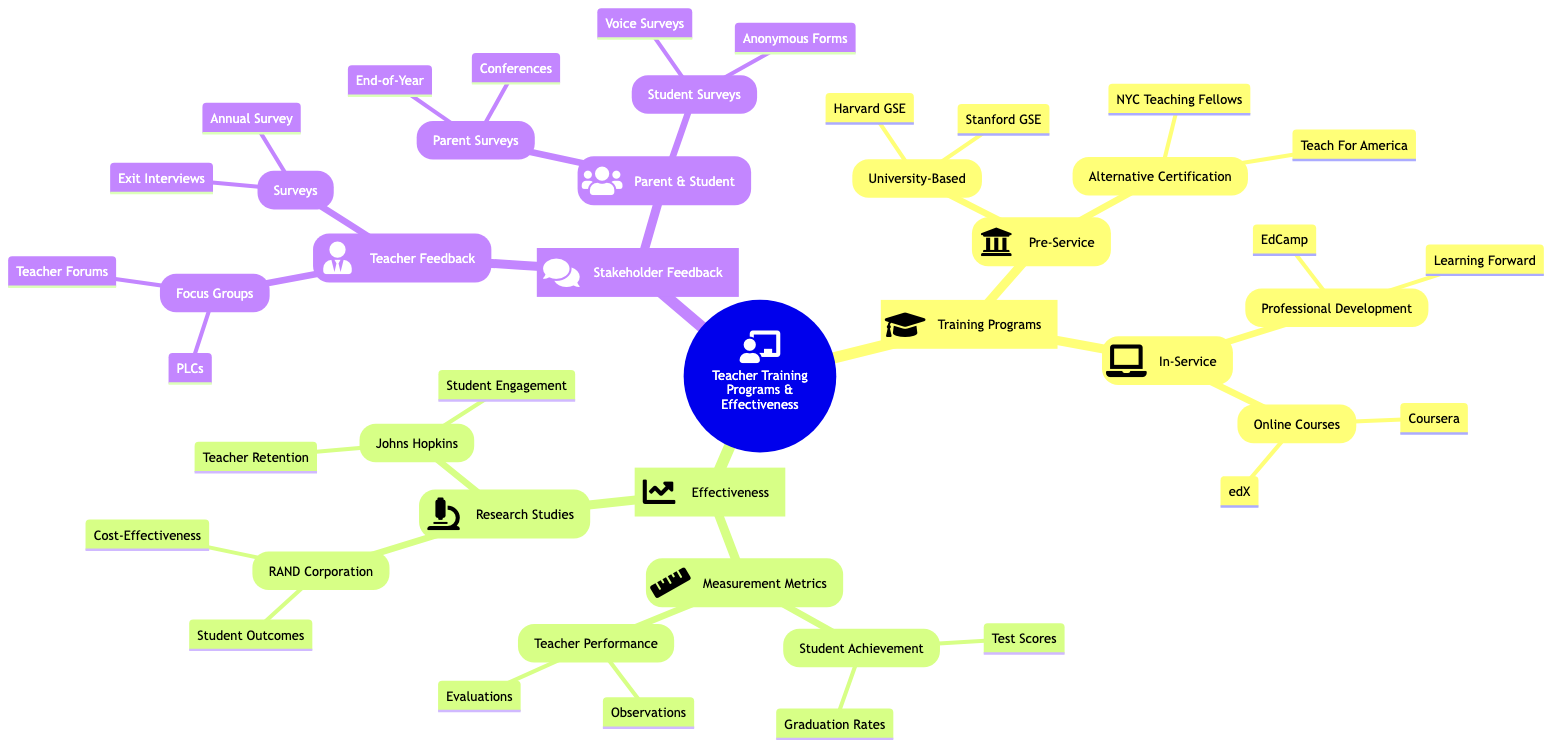What are the two types of Teacher Training Programs? The diagram shows two main categories under Teacher Training Programs: Pre-Service and In-Service training.
Answer: Pre-Service, In-Service How many University-Based programs are listed? In the Pre-Service Training section, under University-Based Programs, there are two specific programs mentioned: Harvard Graduate School of Education and Stanford Graduate School of Education.
Answer: 2 What are the measures used to evaluate Teacher Performance? Under Effectiveness, specifically in the Measurement Metrics, the diagram lists two specific methods for evaluating Teacher Performance: Classroom Observations and Teacher Evaluations.
Answer: Classroom Observations, Teacher Evaluations Which organization is associated with studies on Student Engagement? The Research Studies section of the diagram includes Johns Hopkins University Studies, which specifically mentions Teacher Retention and Student Engagement was associated with this organization.
Answer: Johns Hopkins University What type of feedback is collected from Parents? The Stakeholder Feedback section mentions Parent Surveys, specifically outlining that End-of-Year Surveys and Parent-Teacher Conferences are methods used to collect feedback from parents.
Answer: End-of-Year Surveys, Parent-Teacher Conferences Which In-Service training includes Online Courses? In the In-Service Training section, the diagram categorizes Online Courses under its own sub-category and lists Coursera and edX as the specific examples.
Answer: Coursera, edX What study is associated with Cost-Effectiveness? Under Research Studies, the diagram identifies RAND Corporation Analysis and includes Cost-Effectiveness as one of the topics studied by this organization.
Answer: RAND Corporation Name one method used in Teacher Feedback collection. The diagram shows that in the Teacher Feedback category, there are Surveys as one method used to gather feedback, specifically including Annual Teacher Survey and Exit Interviews as examples.
Answer: Surveys 